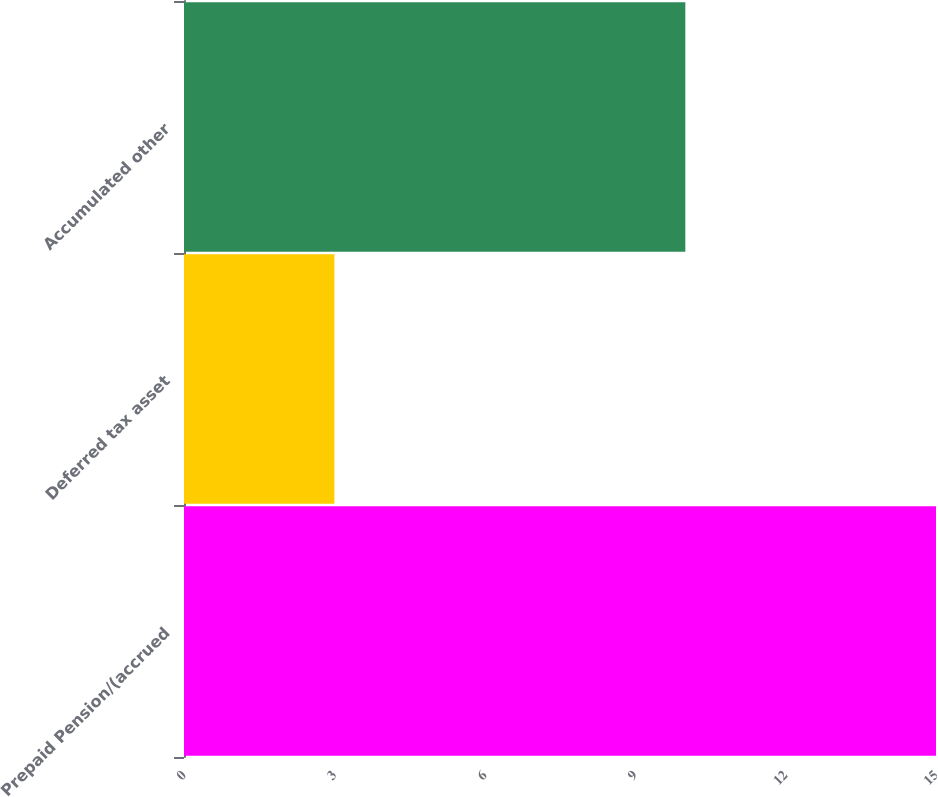Convert chart. <chart><loc_0><loc_0><loc_500><loc_500><bar_chart><fcel>Prepaid Pension/(accrued<fcel>Deferred tax asset<fcel>Accumulated other<nl><fcel>15<fcel>3<fcel>10<nl></chart> 